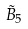Convert formula to latex. <formula><loc_0><loc_0><loc_500><loc_500>\tilde { B } _ { 5 }</formula> 